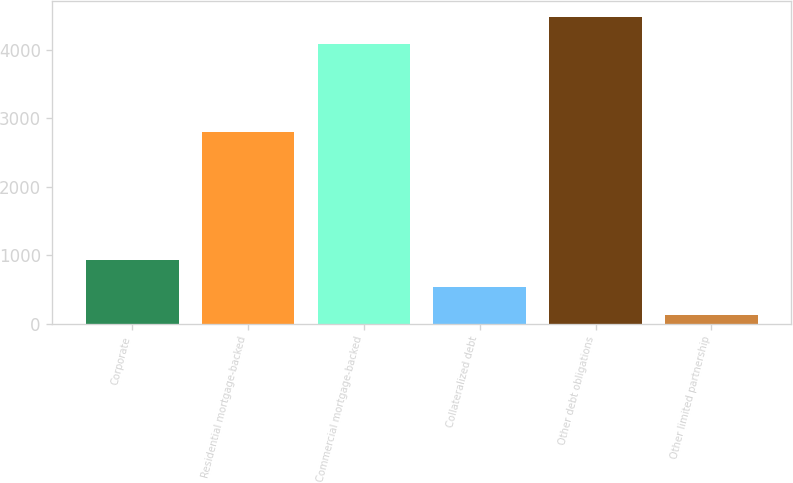Convert chart. <chart><loc_0><loc_0><loc_500><loc_500><bar_chart><fcel>Corporate<fcel>Residential mortgage-backed<fcel>Commercial mortgage-backed<fcel>Collateralized debt<fcel>Other debt obligations<fcel>Other limited partnership<nl><fcel>930.3<fcel>2799.1<fcel>4078<fcel>526.9<fcel>4481.4<fcel>123.5<nl></chart> 